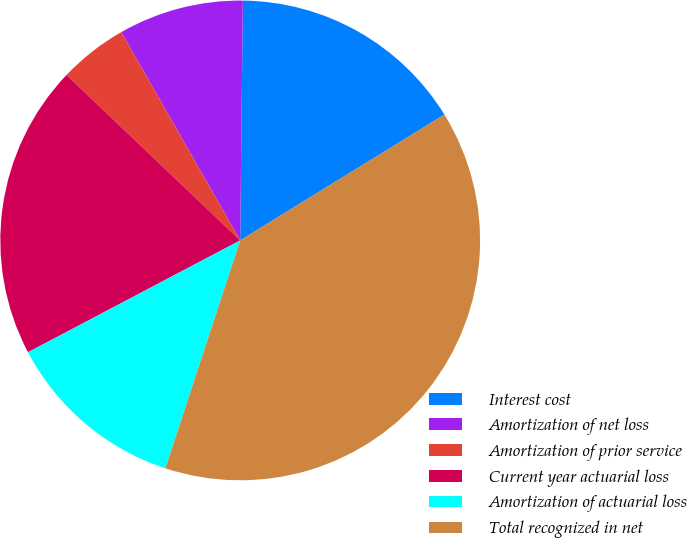Convert chart. <chart><loc_0><loc_0><loc_500><loc_500><pie_chart><fcel>Interest cost<fcel>Amortization of net loss<fcel>Amortization of prior service<fcel>Current year actuarial loss<fcel>Amortization of actuarial loss<fcel>Total recognized in net<nl><fcel>16.03%<fcel>8.43%<fcel>4.63%<fcel>19.83%<fcel>12.23%<fcel>38.83%<nl></chart> 